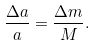<formula> <loc_0><loc_0><loc_500><loc_500>\frac { \Delta a } { a } = \frac { \Delta m } { M } .</formula> 